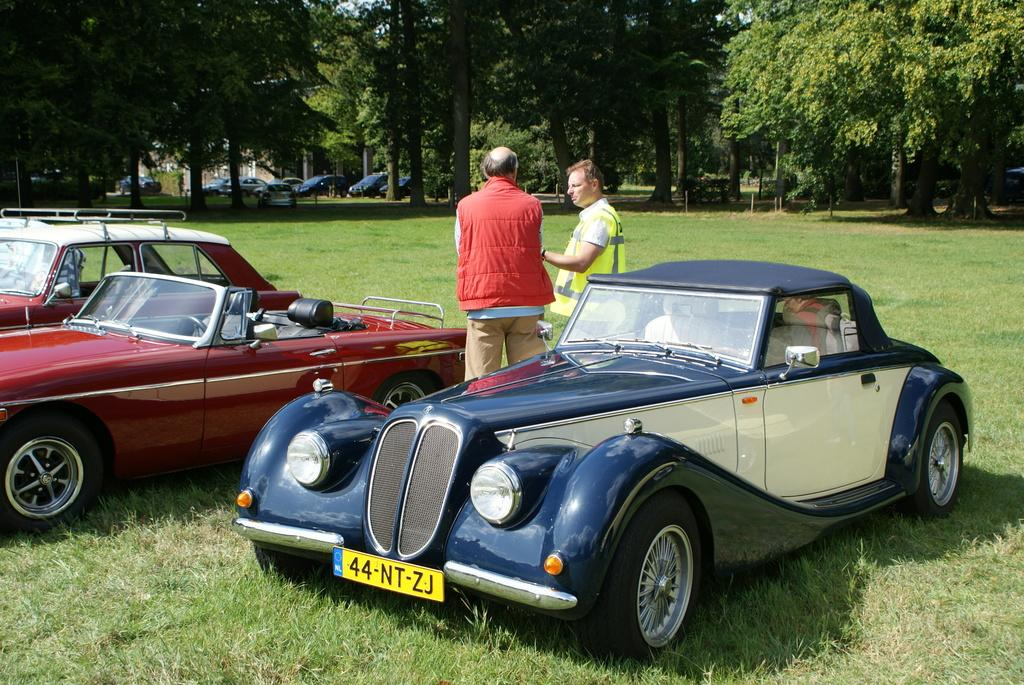What types of vehicles can be seen in the image? There are many vehicles of different colors and shapes in the image. Can you describe the people in the image? Two men are standing in the image, and they are wearing clothes. What type of natural environment is visible in the image? There is grass and trees visible in the image. How would you describe the sky in the image? The sky is white in the image. How many cords are connected to the vehicles in the image? There are no cords connected to the vehicles in the image. Who is the manager of the men in the image? There is no indication of a manager or any hierarchical relationship between the men in the image. 